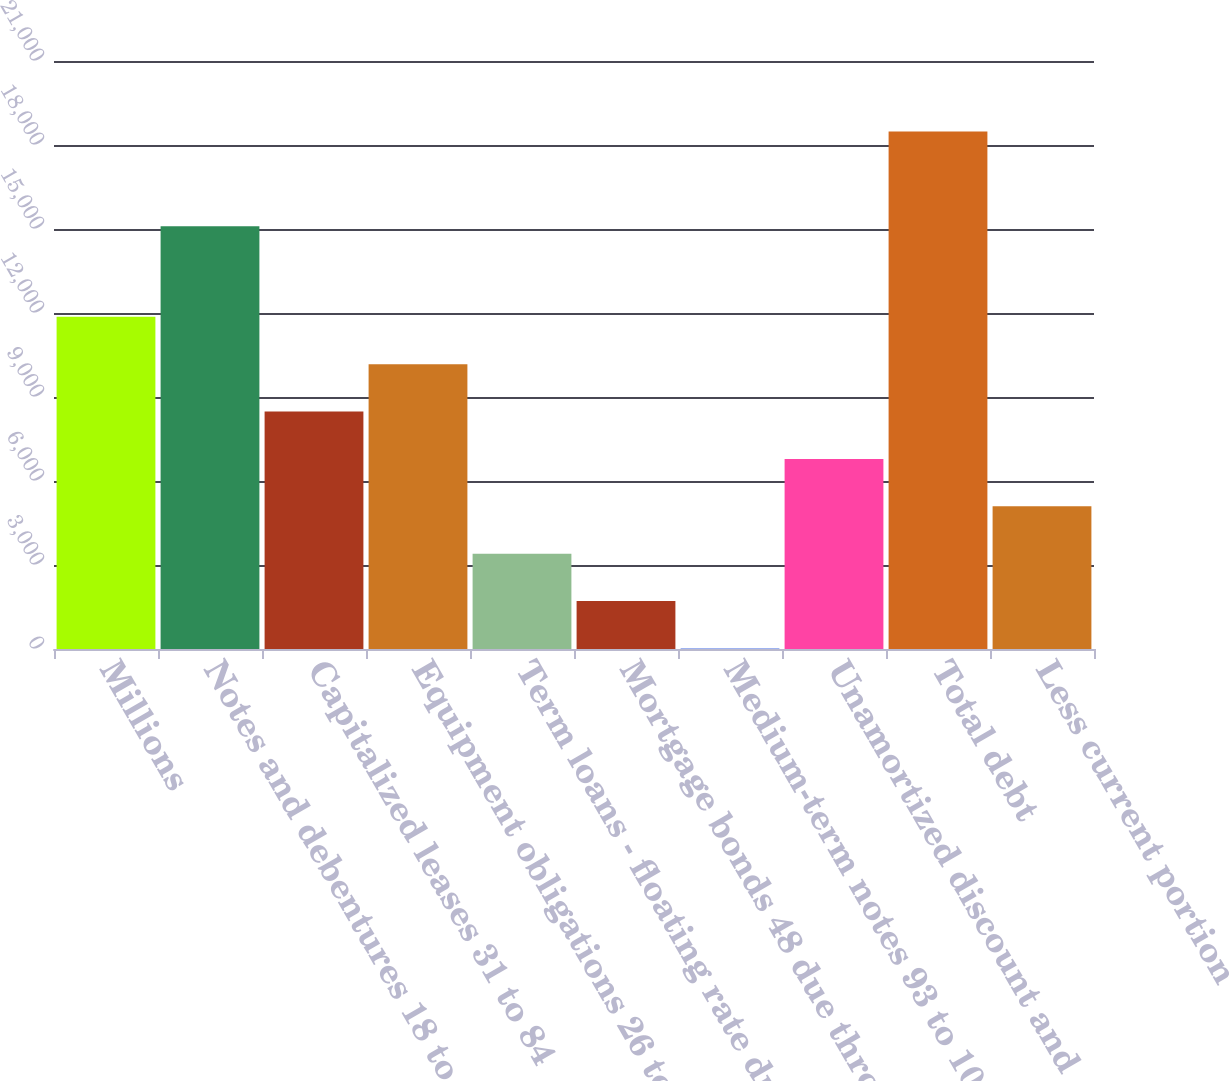<chart> <loc_0><loc_0><loc_500><loc_500><bar_chart><fcel>Millions<fcel>Notes and debentures 18 to 79<fcel>Capitalized leases 31 to 84<fcel>Equipment obligations 26 to 67<fcel>Term loans - floating rate due<fcel>Mortgage bonds 48 due through<fcel>Medium-term notes 93 to 100<fcel>Unamortized discount and<fcel>Total debt<fcel>Less current portion<nl><fcel>11866.2<fcel>15096<fcel>8481<fcel>10173.6<fcel>3403.2<fcel>1710.6<fcel>18<fcel>6788.4<fcel>18481.2<fcel>5095.8<nl></chart> 